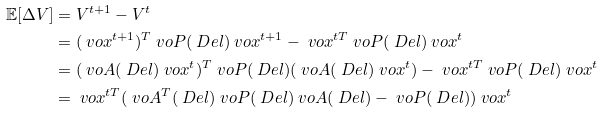<formula> <loc_0><loc_0><loc_500><loc_500>\mathbb { E } [ \Delta V ] & = V ^ { t + 1 } - V ^ { t } \\ & = ( \ v o { x } ^ { t + 1 } ) ^ { T } \ v o { P } ( \ D e l ) \ v o { x } ^ { t + 1 } - \ v o { x } ^ { t T } \ v o { P } ( \ D e l ) \ v o { x } ^ { t } \\ & = ( \ v o { A } ( \ D e l ) \ v o { x } ^ { t } ) ^ { T } \ v o { P } ( \ D e l ) ( \ v o { A } ( \ D e l ) \ v o { x } ^ { t } ) - \ v o { x } ^ { t T } \ v o { P } ( \ D e l ) \ v o { x } ^ { t } \\ & = \ v o { x } ^ { t T } ( \ v o { A } ^ { T } ( \ D e l ) \ v o { P } ( \ D e l ) \ v o { A } ( \ D e l ) - \ v o { P } ( \ D e l ) ) \ v o { x } ^ { t }</formula> 